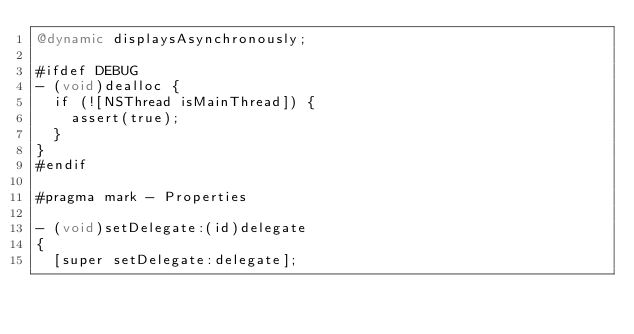Convert code to text. <code><loc_0><loc_0><loc_500><loc_500><_ObjectiveC_>@dynamic displaysAsynchronously;

#ifdef DEBUG
- (void)dealloc {
  if (![NSThread isMainThread]) {
    assert(true);
  }
}
#endif

#pragma mark - Properties

- (void)setDelegate:(id)delegate
{
  [super setDelegate:delegate];</code> 